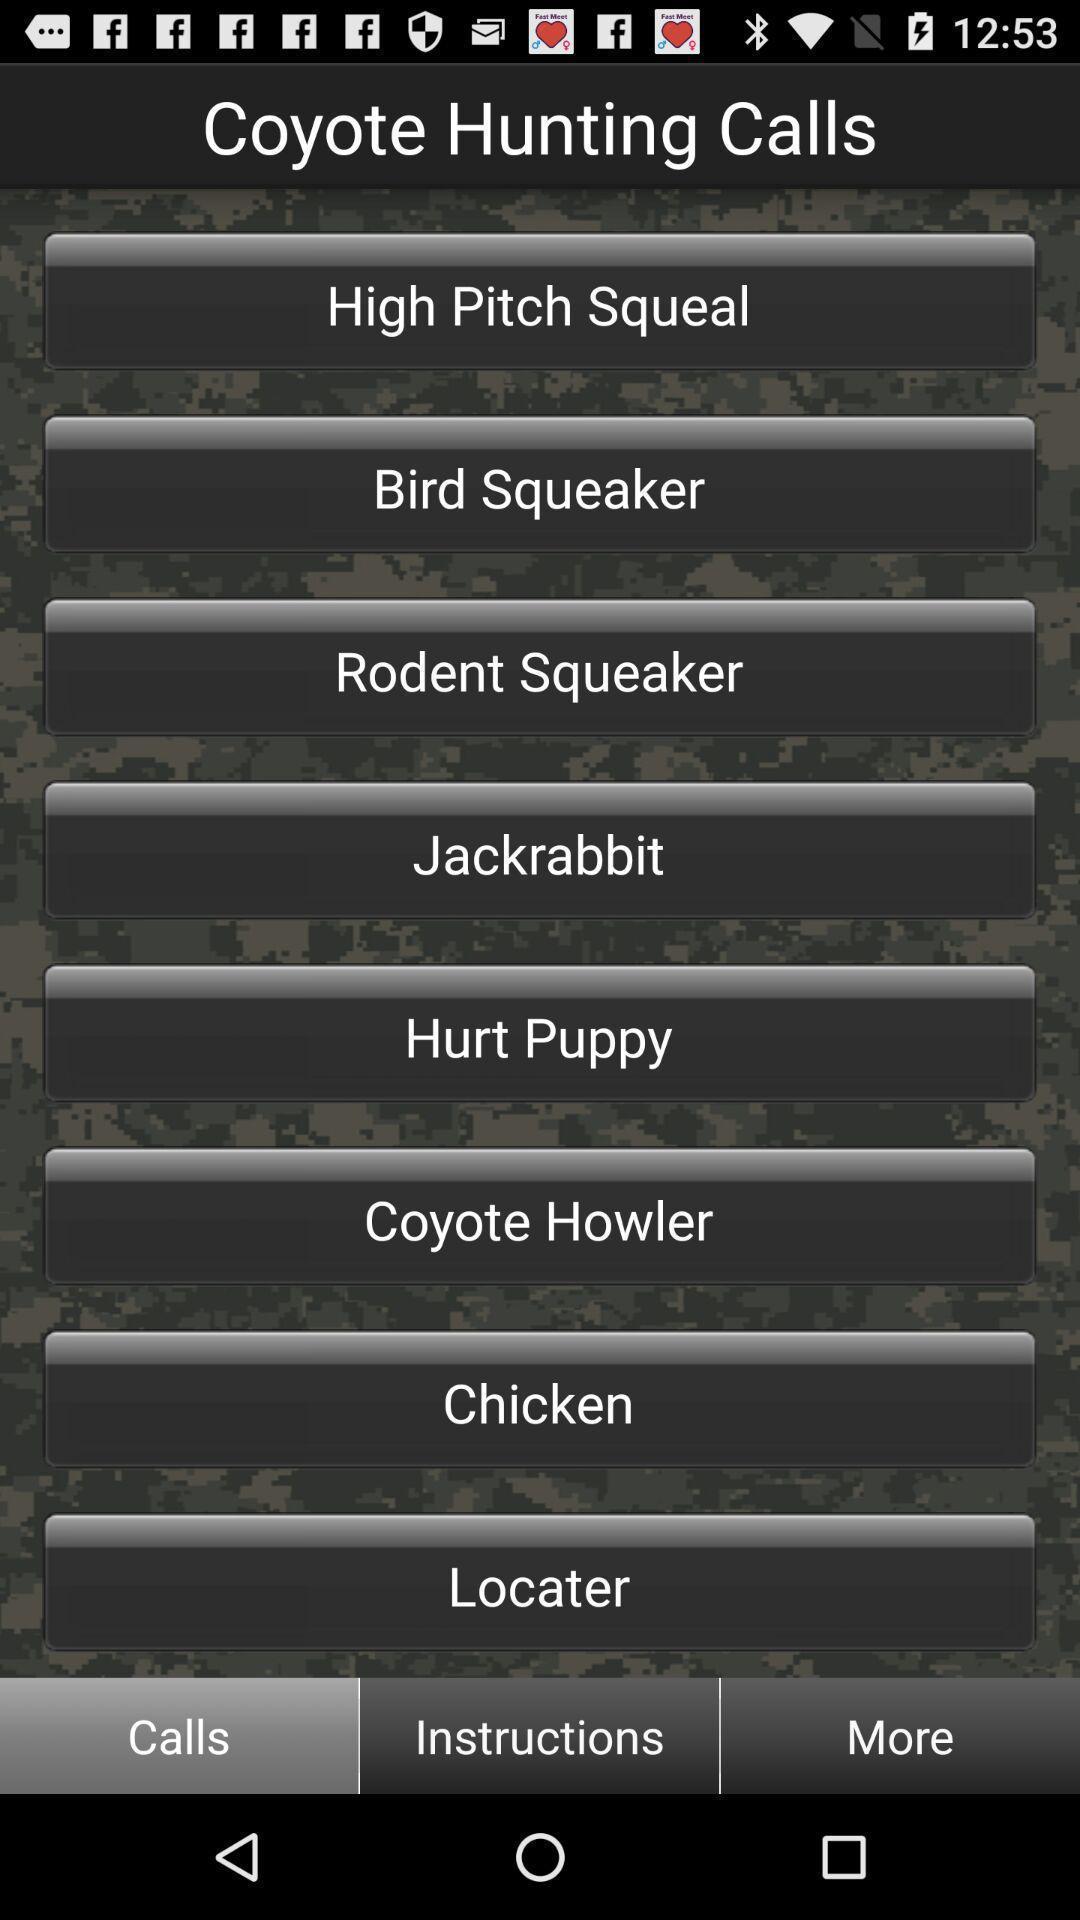Give me a summary of this screen capture. Page showing calls. 